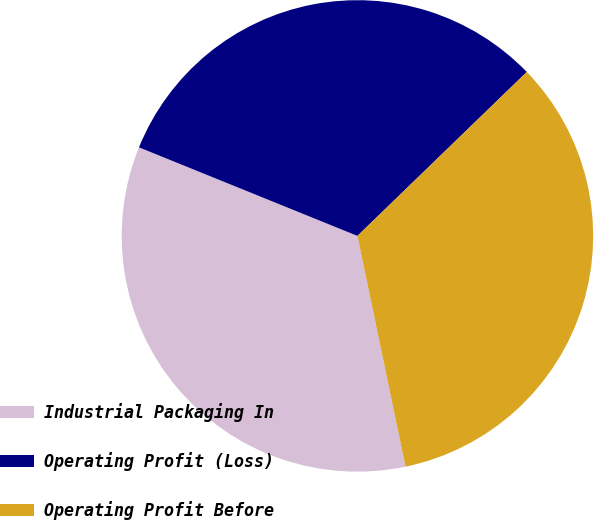Convert chart to OTSL. <chart><loc_0><loc_0><loc_500><loc_500><pie_chart><fcel>Industrial Packaging In<fcel>Operating Profit (Loss)<fcel>Operating Profit Before<nl><fcel>34.4%<fcel>31.63%<fcel>33.97%<nl></chart> 